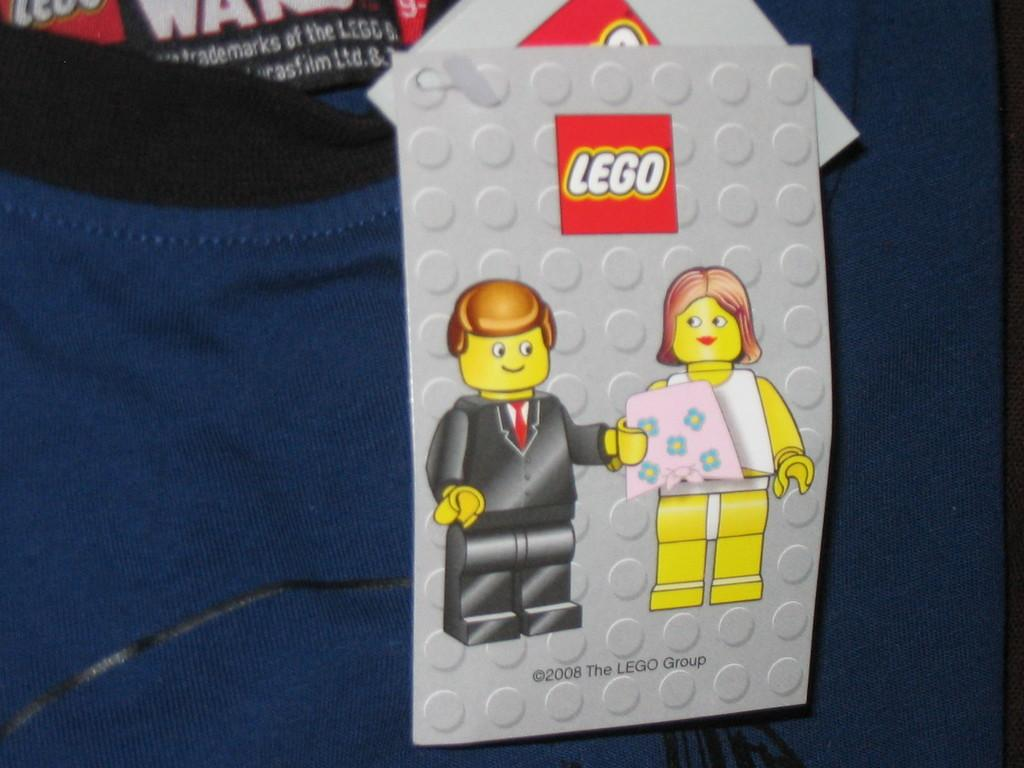<image>
Write a terse but informative summary of the picture. Some clothing that is made by the Lego Group. 